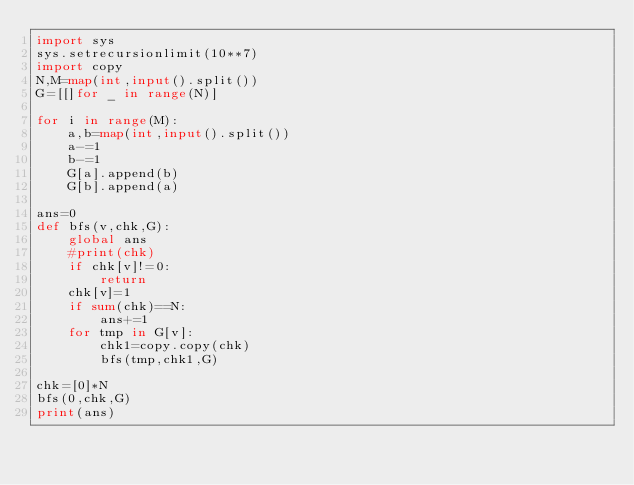Convert code to text. <code><loc_0><loc_0><loc_500><loc_500><_Python_>import sys
sys.setrecursionlimit(10**7)
import copy
N,M=map(int,input().split())
G=[[]for _ in range(N)]

for i in range(M):
    a,b=map(int,input().split())
    a-=1
    b-=1
    G[a].append(b)
    G[b].append(a)

ans=0
def bfs(v,chk,G):
    global ans
    #print(chk)
    if chk[v]!=0:
        return
    chk[v]=1
    if sum(chk)==N:
        ans+=1
    for tmp in G[v]:
        chk1=copy.copy(chk)
        bfs(tmp,chk1,G)

chk=[0]*N
bfs(0,chk,G)
print(ans)</code> 